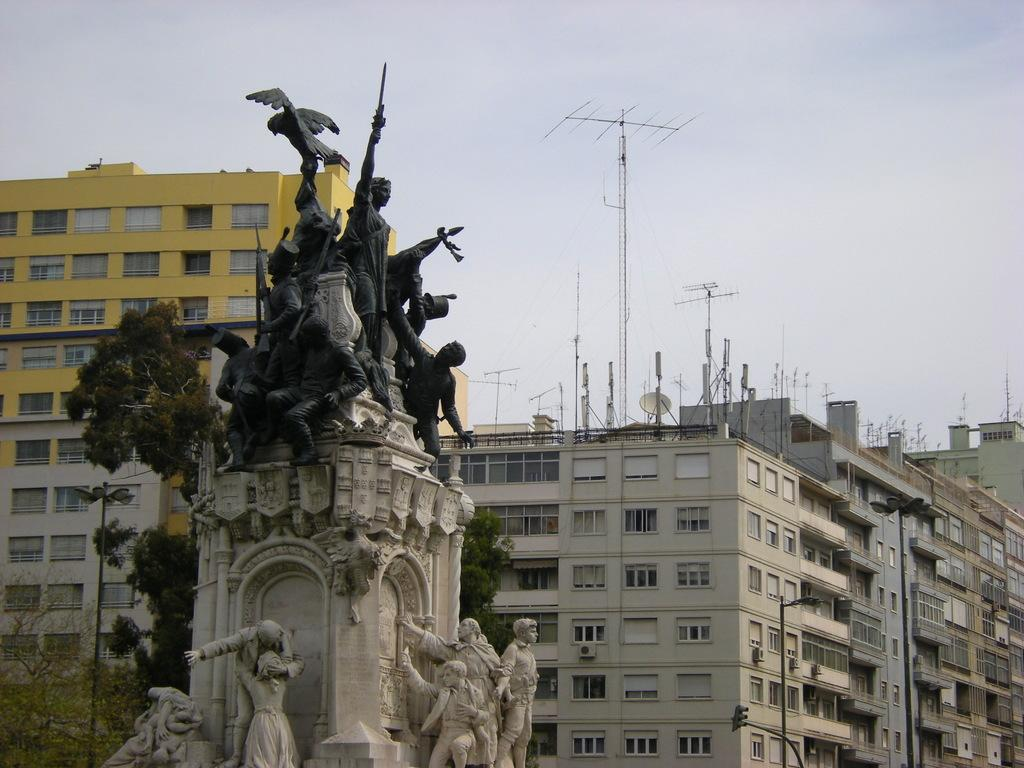What can be seen in the image that represents human-made art or sculpture? There are statues in the image. What can be seen in the background of the image that might indicate a specific location or setting? There are poles, trees, and buildings in the background of the image. What feature can be seen on the buildings in the background? There are antennas on the buildings. Can you describe the lipstick shade of the person in the image? There is no person present in the image, only statues, poles, trees, and buildings. 